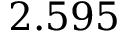Convert formula to latex. <formula><loc_0><loc_0><loc_500><loc_500>2 . 5 9 5</formula> 